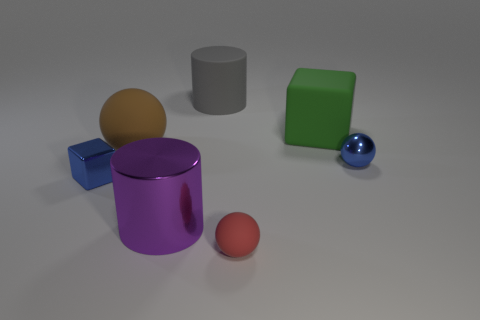Is the color of the tiny shiny block the same as the tiny metallic sphere?
Keep it short and to the point. Yes. What number of objects are matte spheres on the left side of the big gray cylinder or large red matte cylinders?
Make the answer very short. 1. There is a metal block; is it the same color as the metal thing to the right of the purple cylinder?
Your answer should be very brief. Yes. Are there any gray objects of the same size as the rubber block?
Offer a terse response. Yes. There is a block left of the large object that is right of the red rubber sphere; what is it made of?
Provide a short and direct response. Metal. How many tiny metallic cubes are the same color as the metal sphere?
Your response must be concise. 1. There is a purple object that is made of the same material as the blue block; what is its shape?
Your answer should be compact. Cylinder. How big is the block that is in front of the blue ball?
Your answer should be compact. Small. Is the number of brown balls that are in front of the brown matte object the same as the number of tiny blue objects left of the metallic sphere?
Give a very brief answer. No. What color is the big cylinder that is in front of the blue object right of the big brown rubber object that is behind the big metallic thing?
Make the answer very short. Purple. 